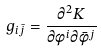<formula> <loc_0><loc_0><loc_500><loc_500>g _ { i \bar { j } } = \frac { \partial ^ { 2 } K } { \partial \phi ^ { i } \partial \bar { \phi } ^ { j } }</formula> 